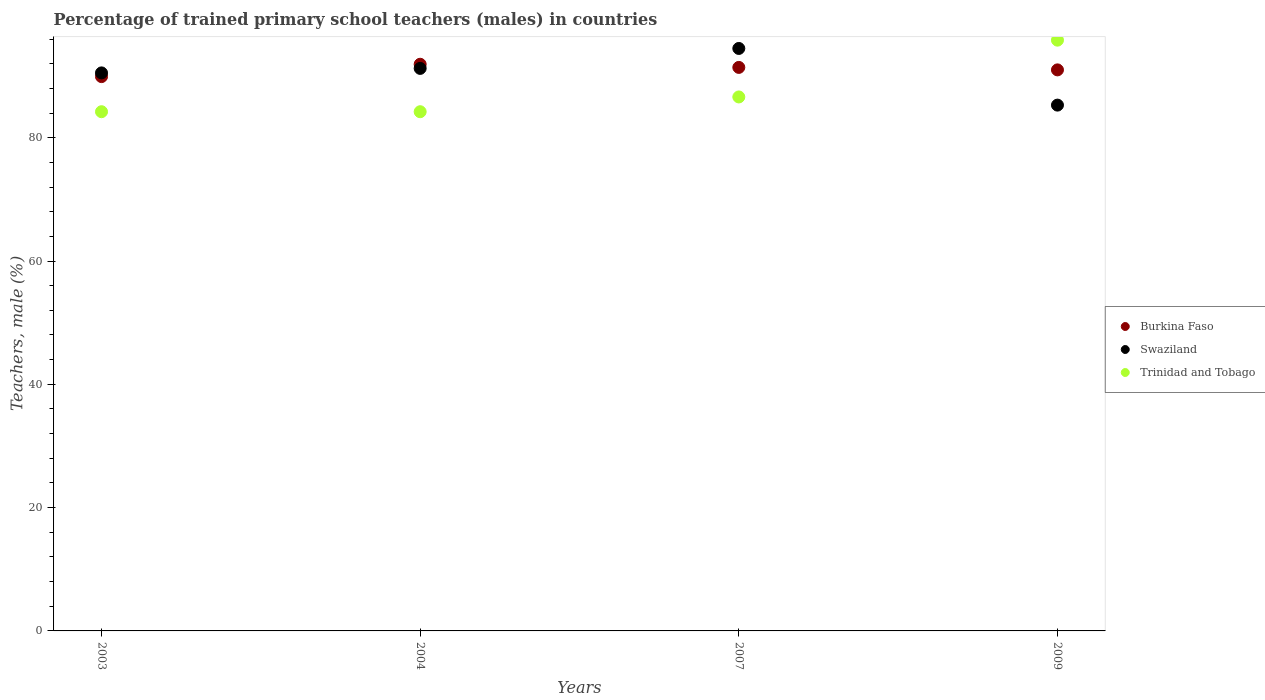How many different coloured dotlines are there?
Ensure brevity in your answer.  3. Is the number of dotlines equal to the number of legend labels?
Your answer should be very brief. Yes. What is the percentage of trained primary school teachers (males) in Burkina Faso in 2003?
Give a very brief answer. 89.91. Across all years, what is the maximum percentage of trained primary school teachers (males) in Trinidad and Tobago?
Give a very brief answer. 95.82. Across all years, what is the minimum percentage of trained primary school teachers (males) in Swaziland?
Your answer should be very brief. 85.29. In which year was the percentage of trained primary school teachers (males) in Trinidad and Tobago maximum?
Your answer should be compact. 2009. What is the total percentage of trained primary school teachers (males) in Swaziland in the graph?
Give a very brief answer. 361.52. What is the difference between the percentage of trained primary school teachers (males) in Trinidad and Tobago in 2003 and that in 2007?
Ensure brevity in your answer.  -2.4. What is the difference between the percentage of trained primary school teachers (males) in Swaziland in 2004 and the percentage of trained primary school teachers (males) in Burkina Faso in 2009?
Your response must be concise. 0.24. What is the average percentage of trained primary school teachers (males) in Burkina Faso per year?
Your response must be concise. 91.06. In the year 2004, what is the difference between the percentage of trained primary school teachers (males) in Swaziland and percentage of trained primary school teachers (males) in Trinidad and Tobago?
Your response must be concise. 7.03. In how many years, is the percentage of trained primary school teachers (males) in Burkina Faso greater than 20 %?
Provide a short and direct response. 4. What is the ratio of the percentage of trained primary school teachers (males) in Swaziland in 2004 to that in 2009?
Provide a succinct answer. 1.07. Is the difference between the percentage of trained primary school teachers (males) in Swaziland in 2003 and 2007 greater than the difference between the percentage of trained primary school teachers (males) in Trinidad and Tobago in 2003 and 2007?
Keep it short and to the point. No. What is the difference between the highest and the second highest percentage of trained primary school teachers (males) in Swaziland?
Your answer should be very brief. 3.23. What is the difference between the highest and the lowest percentage of trained primary school teachers (males) in Swaziland?
Your answer should be compact. 9.19. Does the percentage of trained primary school teachers (males) in Swaziland monotonically increase over the years?
Offer a very short reply. No. Is the percentage of trained primary school teachers (males) in Swaziland strictly greater than the percentage of trained primary school teachers (males) in Burkina Faso over the years?
Provide a short and direct response. No. How many dotlines are there?
Offer a very short reply. 3. Where does the legend appear in the graph?
Ensure brevity in your answer.  Center right. How many legend labels are there?
Your answer should be very brief. 3. What is the title of the graph?
Offer a terse response. Percentage of trained primary school teachers (males) in countries. What is the label or title of the X-axis?
Provide a succinct answer. Years. What is the label or title of the Y-axis?
Ensure brevity in your answer.  Teachers, male (%). What is the Teachers, male (%) of Burkina Faso in 2003?
Provide a short and direct response. 89.91. What is the Teachers, male (%) of Swaziland in 2003?
Your answer should be very brief. 90.51. What is the Teachers, male (%) of Trinidad and Tobago in 2003?
Make the answer very short. 84.22. What is the Teachers, male (%) of Burkina Faso in 2004?
Provide a short and direct response. 91.91. What is the Teachers, male (%) of Swaziland in 2004?
Provide a succinct answer. 91.24. What is the Teachers, male (%) of Trinidad and Tobago in 2004?
Provide a short and direct response. 84.22. What is the Teachers, male (%) in Burkina Faso in 2007?
Provide a succinct answer. 91.4. What is the Teachers, male (%) of Swaziland in 2007?
Offer a very short reply. 94.48. What is the Teachers, male (%) of Trinidad and Tobago in 2007?
Provide a short and direct response. 86.61. What is the Teachers, male (%) in Burkina Faso in 2009?
Make the answer very short. 91. What is the Teachers, male (%) of Swaziland in 2009?
Your answer should be very brief. 85.29. What is the Teachers, male (%) in Trinidad and Tobago in 2009?
Your answer should be very brief. 95.82. Across all years, what is the maximum Teachers, male (%) in Burkina Faso?
Ensure brevity in your answer.  91.91. Across all years, what is the maximum Teachers, male (%) in Swaziland?
Offer a very short reply. 94.48. Across all years, what is the maximum Teachers, male (%) in Trinidad and Tobago?
Give a very brief answer. 95.82. Across all years, what is the minimum Teachers, male (%) in Burkina Faso?
Give a very brief answer. 89.91. Across all years, what is the minimum Teachers, male (%) of Swaziland?
Offer a terse response. 85.29. Across all years, what is the minimum Teachers, male (%) of Trinidad and Tobago?
Keep it short and to the point. 84.22. What is the total Teachers, male (%) in Burkina Faso in the graph?
Provide a succinct answer. 364.23. What is the total Teachers, male (%) of Swaziland in the graph?
Give a very brief answer. 361.52. What is the total Teachers, male (%) in Trinidad and Tobago in the graph?
Provide a succinct answer. 350.86. What is the difference between the Teachers, male (%) of Burkina Faso in 2003 and that in 2004?
Keep it short and to the point. -2. What is the difference between the Teachers, male (%) of Swaziland in 2003 and that in 2004?
Your answer should be very brief. -0.73. What is the difference between the Teachers, male (%) of Burkina Faso in 2003 and that in 2007?
Your answer should be very brief. -1.49. What is the difference between the Teachers, male (%) of Swaziland in 2003 and that in 2007?
Your answer should be very brief. -3.96. What is the difference between the Teachers, male (%) in Trinidad and Tobago in 2003 and that in 2007?
Keep it short and to the point. -2.4. What is the difference between the Teachers, male (%) in Burkina Faso in 2003 and that in 2009?
Keep it short and to the point. -1.09. What is the difference between the Teachers, male (%) of Swaziland in 2003 and that in 2009?
Keep it short and to the point. 5.23. What is the difference between the Teachers, male (%) in Trinidad and Tobago in 2003 and that in 2009?
Make the answer very short. -11.61. What is the difference between the Teachers, male (%) of Burkina Faso in 2004 and that in 2007?
Ensure brevity in your answer.  0.51. What is the difference between the Teachers, male (%) of Swaziland in 2004 and that in 2007?
Keep it short and to the point. -3.23. What is the difference between the Teachers, male (%) in Trinidad and Tobago in 2004 and that in 2007?
Give a very brief answer. -2.4. What is the difference between the Teachers, male (%) in Burkina Faso in 2004 and that in 2009?
Your response must be concise. 0.91. What is the difference between the Teachers, male (%) in Swaziland in 2004 and that in 2009?
Your answer should be very brief. 5.96. What is the difference between the Teachers, male (%) in Trinidad and Tobago in 2004 and that in 2009?
Provide a succinct answer. -11.61. What is the difference between the Teachers, male (%) in Burkina Faso in 2007 and that in 2009?
Your response must be concise. 0.4. What is the difference between the Teachers, male (%) of Swaziland in 2007 and that in 2009?
Give a very brief answer. 9.19. What is the difference between the Teachers, male (%) in Trinidad and Tobago in 2007 and that in 2009?
Make the answer very short. -9.21. What is the difference between the Teachers, male (%) in Burkina Faso in 2003 and the Teachers, male (%) in Swaziland in 2004?
Offer a very short reply. -1.33. What is the difference between the Teachers, male (%) of Burkina Faso in 2003 and the Teachers, male (%) of Trinidad and Tobago in 2004?
Ensure brevity in your answer.  5.7. What is the difference between the Teachers, male (%) in Swaziland in 2003 and the Teachers, male (%) in Trinidad and Tobago in 2004?
Provide a succinct answer. 6.3. What is the difference between the Teachers, male (%) in Burkina Faso in 2003 and the Teachers, male (%) in Swaziland in 2007?
Ensure brevity in your answer.  -4.57. What is the difference between the Teachers, male (%) in Burkina Faso in 2003 and the Teachers, male (%) in Trinidad and Tobago in 2007?
Your response must be concise. 3.3. What is the difference between the Teachers, male (%) of Swaziland in 2003 and the Teachers, male (%) of Trinidad and Tobago in 2007?
Keep it short and to the point. 3.9. What is the difference between the Teachers, male (%) in Burkina Faso in 2003 and the Teachers, male (%) in Swaziland in 2009?
Your answer should be compact. 4.62. What is the difference between the Teachers, male (%) in Burkina Faso in 2003 and the Teachers, male (%) in Trinidad and Tobago in 2009?
Offer a very short reply. -5.91. What is the difference between the Teachers, male (%) in Swaziland in 2003 and the Teachers, male (%) in Trinidad and Tobago in 2009?
Give a very brief answer. -5.31. What is the difference between the Teachers, male (%) in Burkina Faso in 2004 and the Teachers, male (%) in Swaziland in 2007?
Make the answer very short. -2.56. What is the difference between the Teachers, male (%) of Burkina Faso in 2004 and the Teachers, male (%) of Trinidad and Tobago in 2007?
Provide a succinct answer. 5.3. What is the difference between the Teachers, male (%) of Swaziland in 2004 and the Teachers, male (%) of Trinidad and Tobago in 2007?
Your answer should be compact. 4.63. What is the difference between the Teachers, male (%) of Burkina Faso in 2004 and the Teachers, male (%) of Swaziland in 2009?
Provide a short and direct response. 6.63. What is the difference between the Teachers, male (%) of Burkina Faso in 2004 and the Teachers, male (%) of Trinidad and Tobago in 2009?
Provide a succinct answer. -3.91. What is the difference between the Teachers, male (%) in Swaziland in 2004 and the Teachers, male (%) in Trinidad and Tobago in 2009?
Your response must be concise. -4.58. What is the difference between the Teachers, male (%) in Burkina Faso in 2007 and the Teachers, male (%) in Swaziland in 2009?
Your answer should be very brief. 6.12. What is the difference between the Teachers, male (%) in Burkina Faso in 2007 and the Teachers, male (%) in Trinidad and Tobago in 2009?
Keep it short and to the point. -4.42. What is the difference between the Teachers, male (%) in Swaziland in 2007 and the Teachers, male (%) in Trinidad and Tobago in 2009?
Give a very brief answer. -1.35. What is the average Teachers, male (%) of Burkina Faso per year?
Ensure brevity in your answer.  91.06. What is the average Teachers, male (%) in Swaziland per year?
Provide a short and direct response. 90.38. What is the average Teachers, male (%) in Trinidad and Tobago per year?
Offer a terse response. 87.72. In the year 2003, what is the difference between the Teachers, male (%) in Burkina Faso and Teachers, male (%) in Swaziland?
Ensure brevity in your answer.  -0.6. In the year 2003, what is the difference between the Teachers, male (%) of Burkina Faso and Teachers, male (%) of Trinidad and Tobago?
Offer a terse response. 5.7. In the year 2003, what is the difference between the Teachers, male (%) in Swaziland and Teachers, male (%) in Trinidad and Tobago?
Your answer should be compact. 6.3. In the year 2004, what is the difference between the Teachers, male (%) in Burkina Faso and Teachers, male (%) in Swaziland?
Your answer should be compact. 0.67. In the year 2004, what is the difference between the Teachers, male (%) of Burkina Faso and Teachers, male (%) of Trinidad and Tobago?
Your answer should be very brief. 7.7. In the year 2004, what is the difference between the Teachers, male (%) of Swaziland and Teachers, male (%) of Trinidad and Tobago?
Your answer should be very brief. 7.03. In the year 2007, what is the difference between the Teachers, male (%) in Burkina Faso and Teachers, male (%) in Swaziland?
Your response must be concise. -3.07. In the year 2007, what is the difference between the Teachers, male (%) of Burkina Faso and Teachers, male (%) of Trinidad and Tobago?
Provide a short and direct response. 4.79. In the year 2007, what is the difference between the Teachers, male (%) in Swaziland and Teachers, male (%) in Trinidad and Tobago?
Provide a short and direct response. 7.87. In the year 2009, what is the difference between the Teachers, male (%) of Burkina Faso and Teachers, male (%) of Swaziland?
Your answer should be very brief. 5.71. In the year 2009, what is the difference between the Teachers, male (%) in Burkina Faso and Teachers, male (%) in Trinidad and Tobago?
Offer a terse response. -4.82. In the year 2009, what is the difference between the Teachers, male (%) in Swaziland and Teachers, male (%) in Trinidad and Tobago?
Ensure brevity in your answer.  -10.54. What is the ratio of the Teachers, male (%) in Burkina Faso in 2003 to that in 2004?
Your answer should be very brief. 0.98. What is the ratio of the Teachers, male (%) in Swaziland in 2003 to that in 2004?
Make the answer very short. 0.99. What is the ratio of the Teachers, male (%) in Trinidad and Tobago in 2003 to that in 2004?
Give a very brief answer. 1. What is the ratio of the Teachers, male (%) of Burkina Faso in 2003 to that in 2007?
Your answer should be compact. 0.98. What is the ratio of the Teachers, male (%) of Swaziland in 2003 to that in 2007?
Make the answer very short. 0.96. What is the ratio of the Teachers, male (%) of Trinidad and Tobago in 2003 to that in 2007?
Offer a terse response. 0.97. What is the ratio of the Teachers, male (%) of Burkina Faso in 2003 to that in 2009?
Provide a short and direct response. 0.99. What is the ratio of the Teachers, male (%) in Swaziland in 2003 to that in 2009?
Provide a succinct answer. 1.06. What is the ratio of the Teachers, male (%) of Trinidad and Tobago in 2003 to that in 2009?
Make the answer very short. 0.88. What is the ratio of the Teachers, male (%) of Burkina Faso in 2004 to that in 2007?
Provide a succinct answer. 1.01. What is the ratio of the Teachers, male (%) in Swaziland in 2004 to that in 2007?
Offer a terse response. 0.97. What is the ratio of the Teachers, male (%) in Trinidad and Tobago in 2004 to that in 2007?
Offer a terse response. 0.97. What is the ratio of the Teachers, male (%) of Burkina Faso in 2004 to that in 2009?
Provide a succinct answer. 1.01. What is the ratio of the Teachers, male (%) in Swaziland in 2004 to that in 2009?
Ensure brevity in your answer.  1.07. What is the ratio of the Teachers, male (%) of Trinidad and Tobago in 2004 to that in 2009?
Provide a short and direct response. 0.88. What is the ratio of the Teachers, male (%) of Burkina Faso in 2007 to that in 2009?
Provide a short and direct response. 1. What is the ratio of the Teachers, male (%) in Swaziland in 2007 to that in 2009?
Your answer should be compact. 1.11. What is the ratio of the Teachers, male (%) in Trinidad and Tobago in 2007 to that in 2009?
Provide a succinct answer. 0.9. What is the difference between the highest and the second highest Teachers, male (%) in Burkina Faso?
Your answer should be compact. 0.51. What is the difference between the highest and the second highest Teachers, male (%) in Swaziland?
Your answer should be compact. 3.23. What is the difference between the highest and the second highest Teachers, male (%) in Trinidad and Tobago?
Your response must be concise. 9.21. What is the difference between the highest and the lowest Teachers, male (%) in Burkina Faso?
Provide a succinct answer. 2. What is the difference between the highest and the lowest Teachers, male (%) of Swaziland?
Give a very brief answer. 9.19. What is the difference between the highest and the lowest Teachers, male (%) in Trinidad and Tobago?
Your answer should be compact. 11.61. 